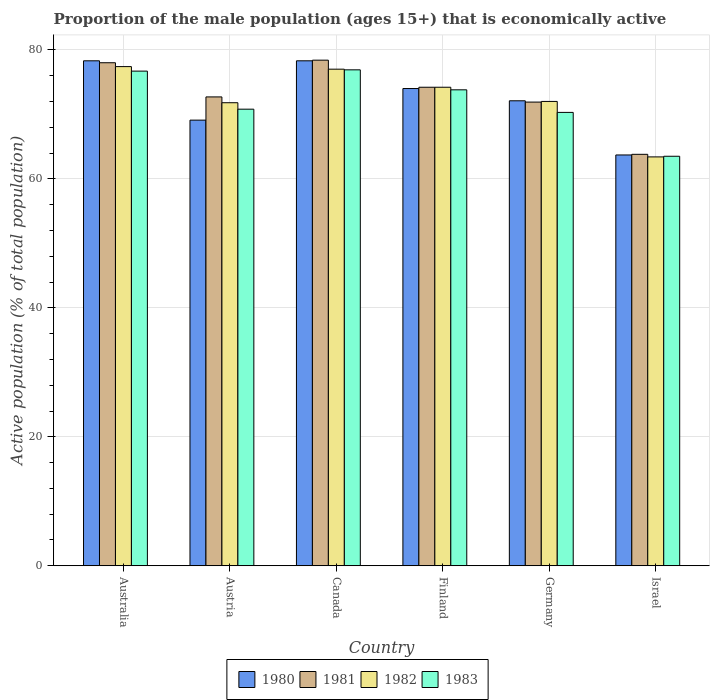Are the number of bars per tick equal to the number of legend labels?
Ensure brevity in your answer.  Yes. Are the number of bars on each tick of the X-axis equal?
Offer a very short reply. Yes. How many bars are there on the 3rd tick from the left?
Your answer should be compact. 4. What is the label of the 5th group of bars from the left?
Give a very brief answer. Germany. In how many cases, is the number of bars for a given country not equal to the number of legend labels?
Provide a short and direct response. 0. What is the proportion of the male population that is economically active in 1983 in Israel?
Offer a very short reply. 63.5. Across all countries, what is the maximum proportion of the male population that is economically active in 1980?
Keep it short and to the point. 78.3. Across all countries, what is the minimum proportion of the male population that is economically active in 1982?
Give a very brief answer. 63.4. In which country was the proportion of the male population that is economically active in 1981 maximum?
Make the answer very short. Canada. In which country was the proportion of the male population that is economically active in 1983 minimum?
Give a very brief answer. Israel. What is the total proportion of the male population that is economically active in 1983 in the graph?
Give a very brief answer. 432. What is the difference between the proportion of the male population that is economically active in 1981 in Austria and that in Canada?
Offer a very short reply. -5.7. What is the difference between the proportion of the male population that is economically active in 1982 in Israel and the proportion of the male population that is economically active in 1983 in Germany?
Keep it short and to the point. -6.9. What is the average proportion of the male population that is economically active in 1982 per country?
Make the answer very short. 72.63. What is the difference between the proportion of the male population that is economically active of/in 1980 and proportion of the male population that is economically active of/in 1982 in Australia?
Make the answer very short. 0.9. What is the ratio of the proportion of the male population that is economically active in 1983 in Austria to that in Israel?
Your answer should be compact. 1.11. Is the proportion of the male population that is economically active in 1982 in Austria less than that in Canada?
Ensure brevity in your answer.  Yes. Is the difference between the proportion of the male population that is economically active in 1980 in Australia and Germany greater than the difference between the proportion of the male population that is economically active in 1982 in Australia and Germany?
Provide a succinct answer. Yes. What is the difference between the highest and the second highest proportion of the male population that is economically active in 1982?
Your answer should be compact. -2.8. What is the difference between the highest and the lowest proportion of the male population that is economically active in 1981?
Give a very brief answer. 14.6. In how many countries, is the proportion of the male population that is economically active in 1980 greater than the average proportion of the male population that is economically active in 1980 taken over all countries?
Provide a short and direct response. 3. Is the sum of the proportion of the male population that is economically active in 1983 in Canada and Israel greater than the maximum proportion of the male population that is economically active in 1980 across all countries?
Your answer should be compact. Yes. Is it the case that in every country, the sum of the proportion of the male population that is economically active in 1980 and proportion of the male population that is economically active in 1983 is greater than the sum of proportion of the male population that is economically active in 1981 and proportion of the male population that is economically active in 1982?
Offer a terse response. No. What does the 2nd bar from the right in Canada represents?
Provide a short and direct response. 1982. Are all the bars in the graph horizontal?
Provide a short and direct response. No. How many countries are there in the graph?
Provide a succinct answer. 6. What is the difference between two consecutive major ticks on the Y-axis?
Offer a very short reply. 20. What is the title of the graph?
Offer a very short reply. Proportion of the male population (ages 15+) that is economically active. Does "2009" appear as one of the legend labels in the graph?
Provide a succinct answer. No. What is the label or title of the Y-axis?
Your response must be concise. Active population (% of total population). What is the Active population (% of total population) of 1980 in Australia?
Ensure brevity in your answer.  78.3. What is the Active population (% of total population) of 1981 in Australia?
Keep it short and to the point. 78. What is the Active population (% of total population) of 1982 in Australia?
Ensure brevity in your answer.  77.4. What is the Active population (% of total population) in 1983 in Australia?
Your answer should be compact. 76.7. What is the Active population (% of total population) in 1980 in Austria?
Offer a very short reply. 69.1. What is the Active population (% of total population) of 1981 in Austria?
Your answer should be compact. 72.7. What is the Active population (% of total population) of 1982 in Austria?
Provide a succinct answer. 71.8. What is the Active population (% of total population) in 1983 in Austria?
Your response must be concise. 70.8. What is the Active population (% of total population) of 1980 in Canada?
Keep it short and to the point. 78.3. What is the Active population (% of total population) of 1981 in Canada?
Your answer should be compact. 78.4. What is the Active population (% of total population) of 1982 in Canada?
Your answer should be very brief. 77. What is the Active population (% of total population) of 1983 in Canada?
Offer a very short reply. 76.9. What is the Active population (% of total population) of 1980 in Finland?
Keep it short and to the point. 74. What is the Active population (% of total population) of 1981 in Finland?
Offer a terse response. 74.2. What is the Active population (% of total population) in 1982 in Finland?
Keep it short and to the point. 74.2. What is the Active population (% of total population) in 1983 in Finland?
Provide a short and direct response. 73.8. What is the Active population (% of total population) in 1980 in Germany?
Give a very brief answer. 72.1. What is the Active population (% of total population) of 1981 in Germany?
Provide a short and direct response. 71.9. What is the Active population (% of total population) of 1982 in Germany?
Provide a short and direct response. 72. What is the Active population (% of total population) of 1983 in Germany?
Ensure brevity in your answer.  70.3. What is the Active population (% of total population) in 1980 in Israel?
Provide a short and direct response. 63.7. What is the Active population (% of total population) in 1981 in Israel?
Your response must be concise. 63.8. What is the Active population (% of total population) of 1982 in Israel?
Your response must be concise. 63.4. What is the Active population (% of total population) in 1983 in Israel?
Offer a terse response. 63.5. Across all countries, what is the maximum Active population (% of total population) of 1980?
Your answer should be very brief. 78.3. Across all countries, what is the maximum Active population (% of total population) in 1981?
Provide a succinct answer. 78.4. Across all countries, what is the maximum Active population (% of total population) in 1982?
Your answer should be very brief. 77.4. Across all countries, what is the maximum Active population (% of total population) of 1983?
Give a very brief answer. 76.9. Across all countries, what is the minimum Active population (% of total population) in 1980?
Your answer should be compact. 63.7. Across all countries, what is the minimum Active population (% of total population) in 1981?
Offer a very short reply. 63.8. Across all countries, what is the minimum Active population (% of total population) in 1982?
Your response must be concise. 63.4. Across all countries, what is the minimum Active population (% of total population) of 1983?
Provide a succinct answer. 63.5. What is the total Active population (% of total population) of 1980 in the graph?
Keep it short and to the point. 435.5. What is the total Active population (% of total population) of 1981 in the graph?
Offer a very short reply. 439. What is the total Active population (% of total population) of 1982 in the graph?
Keep it short and to the point. 435.8. What is the total Active population (% of total population) of 1983 in the graph?
Ensure brevity in your answer.  432. What is the difference between the Active population (% of total population) in 1980 in Australia and that in Austria?
Your response must be concise. 9.2. What is the difference between the Active population (% of total population) in 1983 in Australia and that in Austria?
Provide a succinct answer. 5.9. What is the difference between the Active population (% of total population) in 1980 in Australia and that in Canada?
Keep it short and to the point. 0. What is the difference between the Active population (% of total population) in 1982 in Australia and that in Canada?
Give a very brief answer. 0.4. What is the difference between the Active population (% of total population) in 1983 in Australia and that in Canada?
Provide a short and direct response. -0.2. What is the difference between the Active population (% of total population) in 1981 in Australia and that in Finland?
Provide a short and direct response. 3.8. What is the difference between the Active population (% of total population) in 1982 in Australia and that in Finland?
Your answer should be compact. 3.2. What is the difference between the Active population (% of total population) of 1980 in Australia and that in Germany?
Give a very brief answer. 6.2. What is the difference between the Active population (% of total population) in 1981 in Australia and that in Germany?
Ensure brevity in your answer.  6.1. What is the difference between the Active population (% of total population) of 1982 in Australia and that in Germany?
Provide a succinct answer. 5.4. What is the difference between the Active population (% of total population) of 1981 in Australia and that in Israel?
Provide a succinct answer. 14.2. What is the difference between the Active population (% of total population) in 1982 in Australia and that in Israel?
Make the answer very short. 14. What is the difference between the Active population (% of total population) in 1983 in Australia and that in Israel?
Provide a short and direct response. 13.2. What is the difference between the Active population (% of total population) in 1982 in Austria and that in Canada?
Ensure brevity in your answer.  -5.2. What is the difference between the Active population (% of total population) in 1983 in Austria and that in Canada?
Provide a succinct answer. -6.1. What is the difference between the Active population (% of total population) of 1981 in Austria and that in Finland?
Your answer should be very brief. -1.5. What is the difference between the Active population (% of total population) in 1980 in Austria and that in Germany?
Offer a terse response. -3. What is the difference between the Active population (% of total population) of 1981 in Austria and that in Germany?
Make the answer very short. 0.8. What is the difference between the Active population (% of total population) in 1982 in Austria and that in Germany?
Offer a very short reply. -0.2. What is the difference between the Active population (% of total population) in 1983 in Austria and that in Germany?
Provide a short and direct response. 0.5. What is the difference between the Active population (% of total population) of 1982 in Austria and that in Israel?
Your answer should be very brief. 8.4. What is the difference between the Active population (% of total population) of 1980 in Canada and that in Finland?
Keep it short and to the point. 4.3. What is the difference between the Active population (% of total population) of 1983 in Canada and that in Finland?
Make the answer very short. 3.1. What is the difference between the Active population (% of total population) of 1980 in Canada and that in Germany?
Keep it short and to the point. 6.2. What is the difference between the Active population (% of total population) of 1981 in Canada and that in Germany?
Provide a short and direct response. 6.5. What is the difference between the Active population (% of total population) in 1982 in Canada and that in Germany?
Ensure brevity in your answer.  5. What is the difference between the Active population (% of total population) in 1982 in Canada and that in Israel?
Your answer should be very brief. 13.6. What is the difference between the Active population (% of total population) of 1983 in Canada and that in Israel?
Ensure brevity in your answer.  13.4. What is the difference between the Active population (% of total population) in 1983 in Finland and that in Germany?
Your answer should be very brief. 3.5. What is the difference between the Active population (% of total population) of 1980 in Finland and that in Israel?
Provide a short and direct response. 10.3. What is the difference between the Active population (% of total population) of 1981 in Finland and that in Israel?
Provide a succinct answer. 10.4. What is the difference between the Active population (% of total population) in 1982 in Finland and that in Israel?
Your answer should be very brief. 10.8. What is the difference between the Active population (% of total population) of 1983 in Finland and that in Israel?
Make the answer very short. 10.3. What is the difference between the Active population (% of total population) of 1980 in Germany and that in Israel?
Your response must be concise. 8.4. What is the difference between the Active population (% of total population) in 1980 in Australia and the Active population (% of total population) in 1981 in Austria?
Your response must be concise. 5.6. What is the difference between the Active population (% of total population) in 1981 in Australia and the Active population (% of total population) in 1982 in Austria?
Your response must be concise. 6.2. What is the difference between the Active population (% of total population) of 1981 in Australia and the Active population (% of total population) of 1983 in Austria?
Offer a terse response. 7.2. What is the difference between the Active population (% of total population) in 1982 in Australia and the Active population (% of total population) in 1983 in Austria?
Keep it short and to the point. 6.6. What is the difference between the Active population (% of total population) in 1980 in Australia and the Active population (% of total population) in 1981 in Canada?
Provide a succinct answer. -0.1. What is the difference between the Active population (% of total population) in 1981 in Australia and the Active population (% of total population) in 1983 in Canada?
Your answer should be compact. 1.1. What is the difference between the Active population (% of total population) of 1982 in Australia and the Active population (% of total population) of 1983 in Canada?
Ensure brevity in your answer.  0.5. What is the difference between the Active population (% of total population) in 1980 in Australia and the Active population (% of total population) in 1982 in Finland?
Your answer should be compact. 4.1. What is the difference between the Active population (% of total population) in 1981 in Australia and the Active population (% of total population) in 1982 in Finland?
Your answer should be compact. 3.8. What is the difference between the Active population (% of total population) in 1981 in Australia and the Active population (% of total population) in 1983 in Finland?
Ensure brevity in your answer.  4.2. What is the difference between the Active population (% of total population) in 1980 in Australia and the Active population (% of total population) in 1983 in Germany?
Make the answer very short. 8. What is the difference between the Active population (% of total population) in 1981 in Australia and the Active population (% of total population) in 1983 in Germany?
Provide a succinct answer. 7.7. What is the difference between the Active population (% of total population) in 1982 in Australia and the Active population (% of total population) in 1983 in Germany?
Your answer should be very brief. 7.1. What is the difference between the Active population (% of total population) in 1980 in Australia and the Active population (% of total population) in 1981 in Israel?
Your answer should be very brief. 14.5. What is the difference between the Active population (% of total population) of 1980 in Australia and the Active population (% of total population) of 1982 in Israel?
Your response must be concise. 14.9. What is the difference between the Active population (% of total population) of 1981 in Australia and the Active population (% of total population) of 1983 in Israel?
Provide a succinct answer. 14.5. What is the difference between the Active population (% of total population) of 1980 in Austria and the Active population (% of total population) of 1981 in Canada?
Your answer should be compact. -9.3. What is the difference between the Active population (% of total population) of 1980 in Austria and the Active population (% of total population) of 1982 in Canada?
Offer a very short reply. -7.9. What is the difference between the Active population (% of total population) in 1980 in Austria and the Active population (% of total population) in 1983 in Canada?
Your answer should be compact. -7.8. What is the difference between the Active population (% of total population) of 1981 in Austria and the Active population (% of total population) of 1982 in Canada?
Keep it short and to the point. -4.3. What is the difference between the Active population (% of total population) of 1981 in Austria and the Active population (% of total population) of 1983 in Canada?
Keep it short and to the point. -4.2. What is the difference between the Active population (% of total population) of 1982 in Austria and the Active population (% of total population) of 1983 in Canada?
Ensure brevity in your answer.  -5.1. What is the difference between the Active population (% of total population) of 1980 in Austria and the Active population (% of total population) of 1981 in Finland?
Keep it short and to the point. -5.1. What is the difference between the Active population (% of total population) in 1980 in Austria and the Active population (% of total population) in 1982 in Finland?
Your response must be concise. -5.1. What is the difference between the Active population (% of total population) in 1980 in Austria and the Active population (% of total population) in 1983 in Finland?
Provide a succinct answer. -4.7. What is the difference between the Active population (% of total population) in 1981 in Austria and the Active population (% of total population) in 1982 in Finland?
Give a very brief answer. -1.5. What is the difference between the Active population (% of total population) of 1981 in Austria and the Active population (% of total population) of 1983 in Finland?
Your answer should be compact. -1.1. What is the difference between the Active population (% of total population) of 1982 in Austria and the Active population (% of total population) of 1983 in Finland?
Make the answer very short. -2. What is the difference between the Active population (% of total population) of 1980 in Austria and the Active population (% of total population) of 1981 in Germany?
Give a very brief answer. -2.8. What is the difference between the Active population (% of total population) of 1980 in Austria and the Active population (% of total population) of 1982 in Germany?
Your answer should be very brief. -2.9. What is the difference between the Active population (% of total population) of 1980 in Austria and the Active population (% of total population) of 1983 in Germany?
Your answer should be very brief. -1.2. What is the difference between the Active population (% of total population) of 1981 in Austria and the Active population (% of total population) of 1982 in Germany?
Provide a short and direct response. 0.7. What is the difference between the Active population (% of total population) of 1981 in Austria and the Active population (% of total population) of 1983 in Germany?
Provide a succinct answer. 2.4. What is the difference between the Active population (% of total population) of 1982 in Austria and the Active population (% of total population) of 1983 in Germany?
Your answer should be compact. 1.5. What is the difference between the Active population (% of total population) in 1980 in Austria and the Active population (% of total population) in 1981 in Israel?
Keep it short and to the point. 5.3. What is the difference between the Active population (% of total population) in 1980 in Austria and the Active population (% of total population) in 1982 in Israel?
Offer a very short reply. 5.7. What is the difference between the Active population (% of total population) of 1980 in Austria and the Active population (% of total population) of 1983 in Israel?
Ensure brevity in your answer.  5.6. What is the difference between the Active population (% of total population) in 1981 in Austria and the Active population (% of total population) in 1982 in Israel?
Your answer should be compact. 9.3. What is the difference between the Active population (% of total population) of 1981 in Austria and the Active population (% of total population) of 1983 in Israel?
Give a very brief answer. 9.2. What is the difference between the Active population (% of total population) of 1981 in Canada and the Active population (% of total population) of 1983 in Finland?
Your answer should be very brief. 4.6. What is the difference between the Active population (% of total population) in 1982 in Canada and the Active population (% of total population) in 1983 in Finland?
Keep it short and to the point. 3.2. What is the difference between the Active population (% of total population) of 1980 in Canada and the Active population (% of total population) of 1981 in Germany?
Give a very brief answer. 6.4. What is the difference between the Active population (% of total population) in 1980 in Canada and the Active population (% of total population) in 1983 in Germany?
Keep it short and to the point. 8. What is the difference between the Active population (% of total population) in 1980 in Canada and the Active population (% of total population) in 1981 in Israel?
Make the answer very short. 14.5. What is the difference between the Active population (% of total population) of 1980 in Canada and the Active population (% of total population) of 1982 in Israel?
Ensure brevity in your answer.  14.9. What is the difference between the Active population (% of total population) of 1980 in Canada and the Active population (% of total population) of 1983 in Israel?
Offer a terse response. 14.8. What is the difference between the Active population (% of total population) in 1981 in Canada and the Active population (% of total population) in 1982 in Israel?
Make the answer very short. 15. What is the difference between the Active population (% of total population) of 1981 in Canada and the Active population (% of total population) of 1983 in Israel?
Give a very brief answer. 14.9. What is the difference between the Active population (% of total population) of 1980 in Finland and the Active population (% of total population) of 1982 in Germany?
Your answer should be compact. 2. What is the difference between the Active population (% of total population) of 1980 in Finland and the Active population (% of total population) of 1983 in Germany?
Your response must be concise. 3.7. What is the difference between the Active population (% of total population) of 1982 in Finland and the Active population (% of total population) of 1983 in Germany?
Provide a short and direct response. 3.9. What is the difference between the Active population (% of total population) in 1980 in Finland and the Active population (% of total population) in 1982 in Israel?
Give a very brief answer. 10.6. What is the difference between the Active population (% of total population) of 1981 in Finland and the Active population (% of total population) of 1982 in Israel?
Your answer should be very brief. 10.8. What is the difference between the Active population (% of total population) of 1982 in Finland and the Active population (% of total population) of 1983 in Israel?
Your answer should be compact. 10.7. What is the difference between the Active population (% of total population) of 1980 in Germany and the Active population (% of total population) of 1982 in Israel?
Provide a short and direct response. 8.7. What is the difference between the Active population (% of total population) of 1981 in Germany and the Active population (% of total population) of 1982 in Israel?
Provide a succinct answer. 8.5. What is the average Active population (% of total population) in 1980 per country?
Offer a very short reply. 72.58. What is the average Active population (% of total population) in 1981 per country?
Ensure brevity in your answer.  73.17. What is the average Active population (% of total population) of 1982 per country?
Provide a short and direct response. 72.63. What is the difference between the Active population (% of total population) of 1980 and Active population (% of total population) of 1982 in Australia?
Provide a short and direct response. 0.9. What is the difference between the Active population (% of total population) of 1980 and Active population (% of total population) of 1983 in Australia?
Provide a short and direct response. 1.6. What is the difference between the Active population (% of total population) in 1982 and Active population (% of total population) in 1983 in Australia?
Keep it short and to the point. 0.7. What is the difference between the Active population (% of total population) of 1980 and Active population (% of total population) of 1981 in Austria?
Provide a succinct answer. -3.6. What is the difference between the Active population (% of total population) of 1982 and Active population (% of total population) of 1983 in Austria?
Provide a short and direct response. 1. What is the difference between the Active population (% of total population) of 1980 and Active population (% of total population) of 1981 in Canada?
Provide a short and direct response. -0.1. What is the difference between the Active population (% of total population) of 1980 and Active population (% of total population) of 1982 in Canada?
Ensure brevity in your answer.  1.3. What is the difference between the Active population (% of total population) of 1980 and Active population (% of total population) of 1983 in Canada?
Provide a short and direct response. 1.4. What is the difference between the Active population (% of total population) in 1982 and Active population (% of total population) in 1983 in Canada?
Offer a very short reply. 0.1. What is the difference between the Active population (% of total population) of 1980 and Active population (% of total population) of 1981 in Finland?
Offer a terse response. -0.2. What is the difference between the Active population (% of total population) in 1980 and Active population (% of total population) in 1982 in Finland?
Provide a short and direct response. -0.2. What is the difference between the Active population (% of total population) in 1981 and Active population (% of total population) in 1982 in Finland?
Offer a terse response. 0. What is the difference between the Active population (% of total population) of 1982 and Active population (% of total population) of 1983 in Finland?
Keep it short and to the point. 0.4. What is the difference between the Active population (% of total population) of 1981 and Active population (% of total population) of 1983 in Germany?
Your answer should be very brief. 1.6. What is the difference between the Active population (% of total population) in 1982 and Active population (% of total population) in 1983 in Germany?
Your response must be concise. 1.7. What is the difference between the Active population (% of total population) in 1980 and Active population (% of total population) in 1983 in Israel?
Make the answer very short. 0.2. What is the difference between the Active population (% of total population) of 1981 and Active population (% of total population) of 1982 in Israel?
Offer a terse response. 0.4. What is the ratio of the Active population (% of total population) of 1980 in Australia to that in Austria?
Give a very brief answer. 1.13. What is the ratio of the Active population (% of total population) of 1981 in Australia to that in Austria?
Make the answer very short. 1.07. What is the ratio of the Active population (% of total population) of 1982 in Australia to that in Austria?
Your response must be concise. 1.08. What is the ratio of the Active population (% of total population) in 1983 in Australia to that in Austria?
Your answer should be very brief. 1.08. What is the ratio of the Active population (% of total population) of 1980 in Australia to that in Canada?
Offer a very short reply. 1. What is the ratio of the Active population (% of total population) in 1980 in Australia to that in Finland?
Give a very brief answer. 1.06. What is the ratio of the Active population (% of total population) in 1981 in Australia to that in Finland?
Offer a very short reply. 1.05. What is the ratio of the Active population (% of total population) in 1982 in Australia to that in Finland?
Keep it short and to the point. 1.04. What is the ratio of the Active population (% of total population) in 1983 in Australia to that in Finland?
Keep it short and to the point. 1.04. What is the ratio of the Active population (% of total population) of 1980 in Australia to that in Germany?
Give a very brief answer. 1.09. What is the ratio of the Active population (% of total population) in 1981 in Australia to that in Germany?
Ensure brevity in your answer.  1.08. What is the ratio of the Active population (% of total population) of 1982 in Australia to that in Germany?
Offer a very short reply. 1.07. What is the ratio of the Active population (% of total population) of 1983 in Australia to that in Germany?
Offer a very short reply. 1.09. What is the ratio of the Active population (% of total population) of 1980 in Australia to that in Israel?
Ensure brevity in your answer.  1.23. What is the ratio of the Active population (% of total population) of 1981 in Australia to that in Israel?
Make the answer very short. 1.22. What is the ratio of the Active population (% of total population) of 1982 in Australia to that in Israel?
Make the answer very short. 1.22. What is the ratio of the Active population (% of total population) of 1983 in Australia to that in Israel?
Provide a succinct answer. 1.21. What is the ratio of the Active population (% of total population) of 1980 in Austria to that in Canada?
Give a very brief answer. 0.88. What is the ratio of the Active population (% of total population) of 1981 in Austria to that in Canada?
Give a very brief answer. 0.93. What is the ratio of the Active population (% of total population) in 1982 in Austria to that in Canada?
Your answer should be compact. 0.93. What is the ratio of the Active population (% of total population) in 1983 in Austria to that in Canada?
Provide a short and direct response. 0.92. What is the ratio of the Active population (% of total population) in 1980 in Austria to that in Finland?
Ensure brevity in your answer.  0.93. What is the ratio of the Active population (% of total population) of 1981 in Austria to that in Finland?
Give a very brief answer. 0.98. What is the ratio of the Active population (% of total population) of 1982 in Austria to that in Finland?
Ensure brevity in your answer.  0.97. What is the ratio of the Active population (% of total population) of 1983 in Austria to that in Finland?
Your answer should be compact. 0.96. What is the ratio of the Active population (% of total population) in 1980 in Austria to that in Germany?
Make the answer very short. 0.96. What is the ratio of the Active population (% of total population) of 1981 in Austria to that in Germany?
Offer a very short reply. 1.01. What is the ratio of the Active population (% of total population) of 1982 in Austria to that in Germany?
Make the answer very short. 1. What is the ratio of the Active population (% of total population) of 1983 in Austria to that in Germany?
Provide a short and direct response. 1.01. What is the ratio of the Active population (% of total population) of 1980 in Austria to that in Israel?
Your answer should be compact. 1.08. What is the ratio of the Active population (% of total population) of 1981 in Austria to that in Israel?
Offer a very short reply. 1.14. What is the ratio of the Active population (% of total population) in 1982 in Austria to that in Israel?
Provide a succinct answer. 1.13. What is the ratio of the Active population (% of total population) in 1983 in Austria to that in Israel?
Offer a very short reply. 1.11. What is the ratio of the Active population (% of total population) of 1980 in Canada to that in Finland?
Provide a succinct answer. 1.06. What is the ratio of the Active population (% of total population) of 1981 in Canada to that in Finland?
Offer a terse response. 1.06. What is the ratio of the Active population (% of total population) of 1982 in Canada to that in Finland?
Your answer should be very brief. 1.04. What is the ratio of the Active population (% of total population) of 1983 in Canada to that in Finland?
Offer a very short reply. 1.04. What is the ratio of the Active population (% of total population) in 1980 in Canada to that in Germany?
Offer a terse response. 1.09. What is the ratio of the Active population (% of total population) of 1981 in Canada to that in Germany?
Keep it short and to the point. 1.09. What is the ratio of the Active population (% of total population) of 1982 in Canada to that in Germany?
Provide a short and direct response. 1.07. What is the ratio of the Active population (% of total population) in 1983 in Canada to that in Germany?
Your response must be concise. 1.09. What is the ratio of the Active population (% of total population) in 1980 in Canada to that in Israel?
Provide a succinct answer. 1.23. What is the ratio of the Active population (% of total population) in 1981 in Canada to that in Israel?
Your response must be concise. 1.23. What is the ratio of the Active population (% of total population) in 1982 in Canada to that in Israel?
Offer a terse response. 1.21. What is the ratio of the Active population (% of total population) in 1983 in Canada to that in Israel?
Your answer should be very brief. 1.21. What is the ratio of the Active population (% of total population) of 1980 in Finland to that in Germany?
Give a very brief answer. 1.03. What is the ratio of the Active population (% of total population) in 1981 in Finland to that in Germany?
Provide a succinct answer. 1.03. What is the ratio of the Active population (% of total population) in 1982 in Finland to that in Germany?
Give a very brief answer. 1.03. What is the ratio of the Active population (% of total population) in 1983 in Finland to that in Germany?
Ensure brevity in your answer.  1.05. What is the ratio of the Active population (% of total population) of 1980 in Finland to that in Israel?
Give a very brief answer. 1.16. What is the ratio of the Active population (% of total population) of 1981 in Finland to that in Israel?
Your answer should be compact. 1.16. What is the ratio of the Active population (% of total population) of 1982 in Finland to that in Israel?
Keep it short and to the point. 1.17. What is the ratio of the Active population (% of total population) in 1983 in Finland to that in Israel?
Your answer should be very brief. 1.16. What is the ratio of the Active population (% of total population) in 1980 in Germany to that in Israel?
Offer a very short reply. 1.13. What is the ratio of the Active population (% of total population) in 1981 in Germany to that in Israel?
Give a very brief answer. 1.13. What is the ratio of the Active population (% of total population) of 1982 in Germany to that in Israel?
Make the answer very short. 1.14. What is the ratio of the Active population (% of total population) of 1983 in Germany to that in Israel?
Offer a terse response. 1.11. What is the difference between the highest and the second highest Active population (% of total population) in 1981?
Your answer should be very brief. 0.4. What is the difference between the highest and the second highest Active population (% of total population) in 1982?
Ensure brevity in your answer.  0.4. What is the difference between the highest and the second highest Active population (% of total population) of 1983?
Ensure brevity in your answer.  0.2. What is the difference between the highest and the lowest Active population (% of total population) in 1980?
Your answer should be compact. 14.6. What is the difference between the highest and the lowest Active population (% of total population) of 1982?
Provide a short and direct response. 14. 